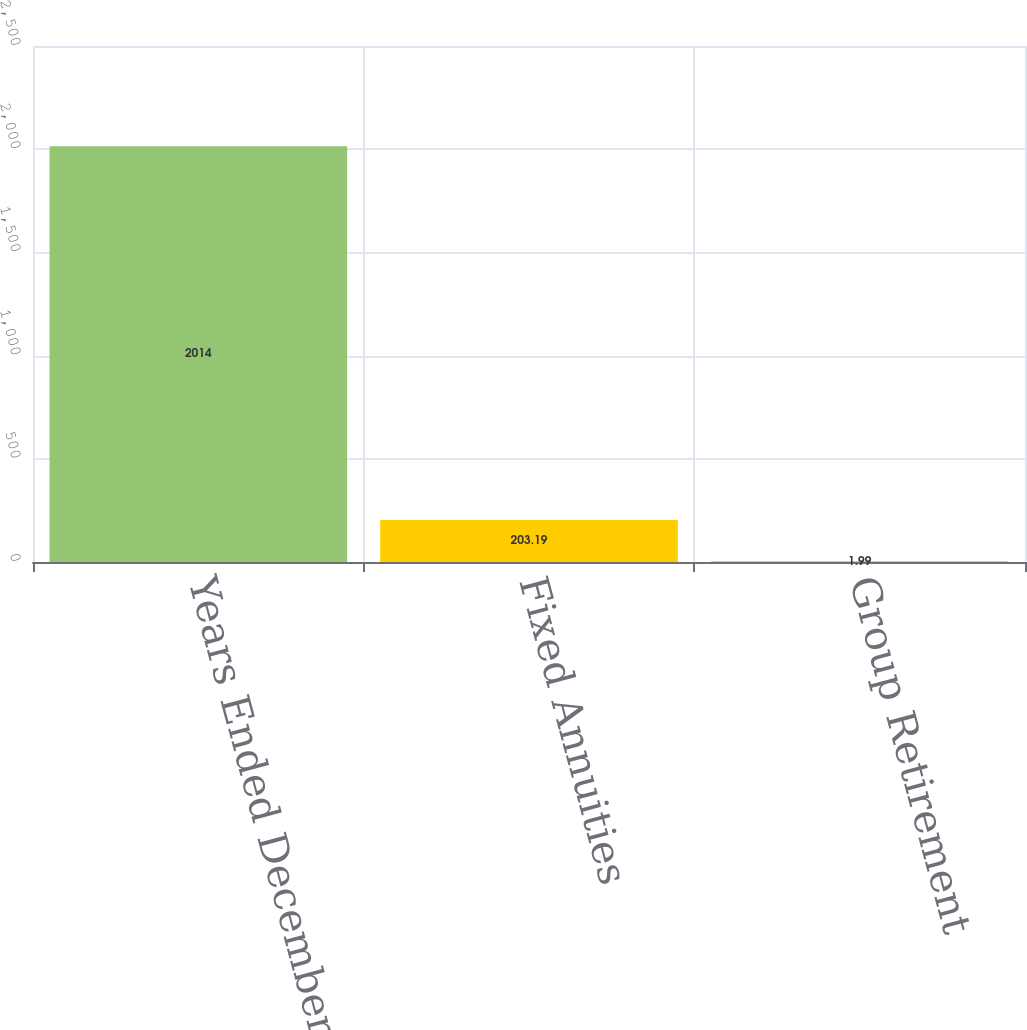<chart> <loc_0><loc_0><loc_500><loc_500><bar_chart><fcel>Years Ended December 31 (in<fcel>Fixed Annuities<fcel>Group Retirement<nl><fcel>2014<fcel>203.19<fcel>1.99<nl></chart> 